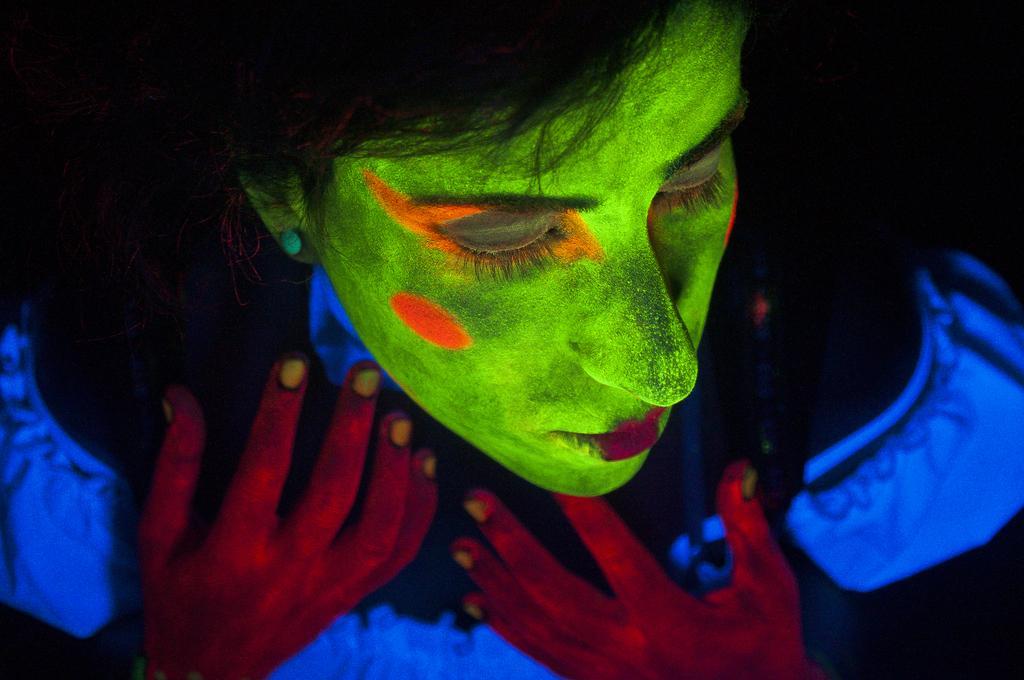Describe this image in one or two sentences. In this image we can see a person wearing black light face painting. 